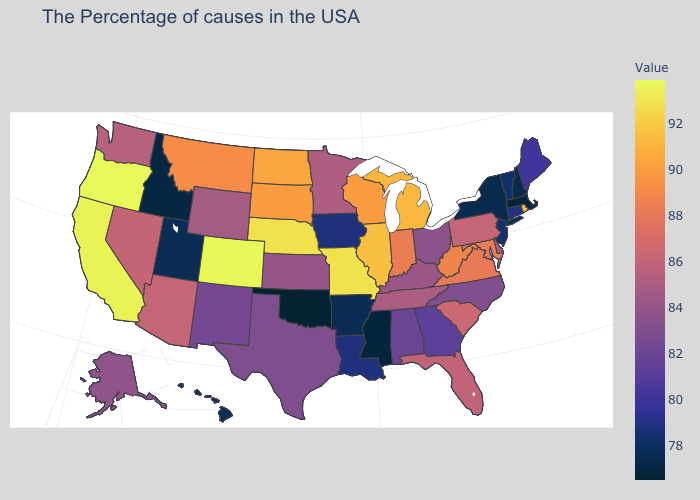Does Alaska have a lower value than Missouri?
Quick response, please. Yes. Does the map have missing data?
Quick response, please. No. Which states hav the highest value in the South?
Keep it brief. West Virginia. Does Missouri have the highest value in the MidWest?
Write a very short answer. Yes. Among the states that border Illinois , which have the highest value?
Keep it brief. Missouri. Which states have the lowest value in the Northeast?
Concise answer only. Massachusetts. Among the states that border Tennessee , which have the highest value?
Write a very short answer. Missouri. 